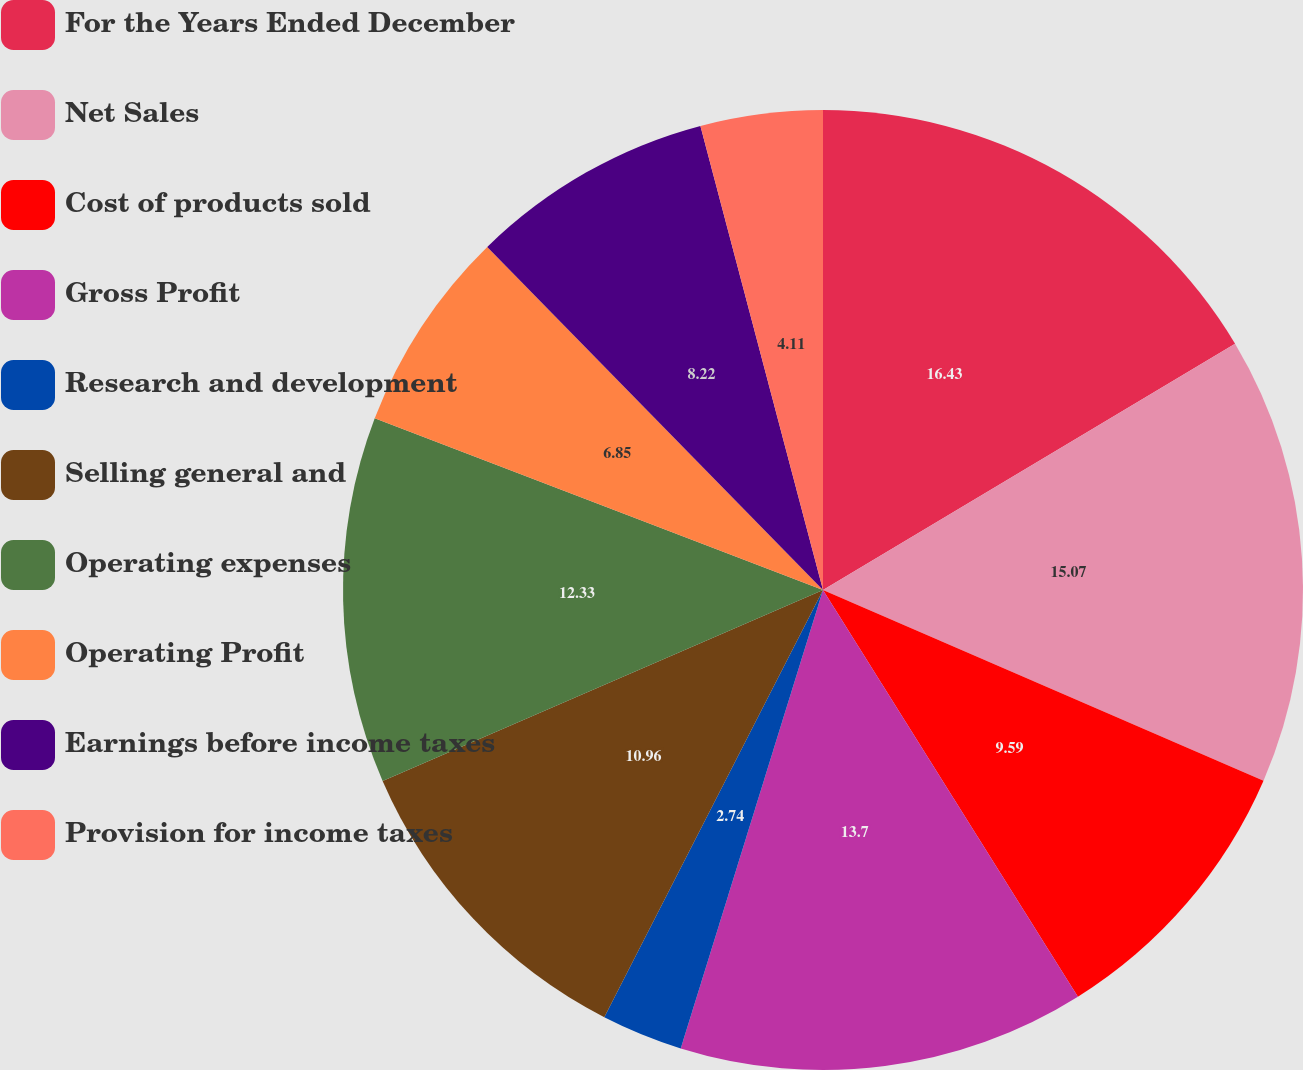Convert chart. <chart><loc_0><loc_0><loc_500><loc_500><pie_chart><fcel>For the Years Ended December<fcel>Net Sales<fcel>Cost of products sold<fcel>Gross Profit<fcel>Research and development<fcel>Selling general and<fcel>Operating expenses<fcel>Operating Profit<fcel>Earnings before income taxes<fcel>Provision for income taxes<nl><fcel>16.43%<fcel>15.07%<fcel>9.59%<fcel>13.7%<fcel>2.74%<fcel>10.96%<fcel>12.33%<fcel>6.85%<fcel>8.22%<fcel>4.11%<nl></chart> 